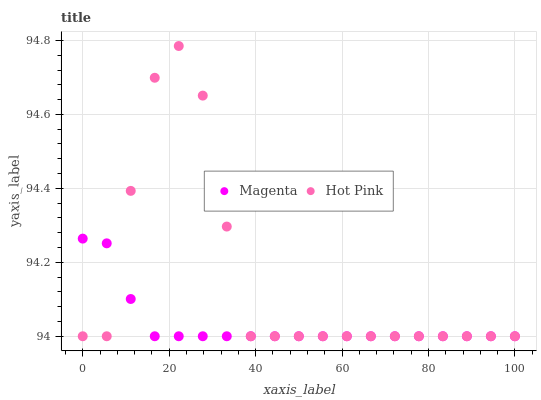Does Magenta have the minimum area under the curve?
Answer yes or no. Yes. Does Hot Pink have the maximum area under the curve?
Answer yes or no. Yes. Does Hot Pink have the minimum area under the curve?
Answer yes or no. No. Is Magenta the smoothest?
Answer yes or no. Yes. Is Hot Pink the roughest?
Answer yes or no. Yes. Is Hot Pink the smoothest?
Answer yes or no. No. Does Magenta have the lowest value?
Answer yes or no. Yes. Does Hot Pink have the highest value?
Answer yes or no. Yes. Does Hot Pink intersect Magenta?
Answer yes or no. Yes. Is Hot Pink less than Magenta?
Answer yes or no. No. Is Hot Pink greater than Magenta?
Answer yes or no. No. 